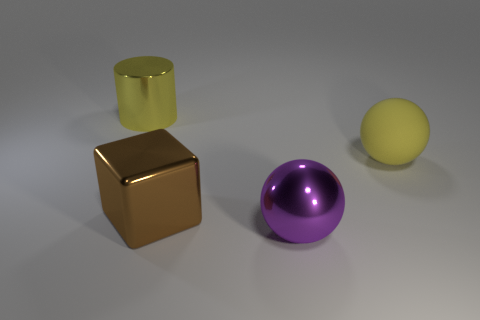Which objects in the image are reflective? The bronze cube and the purple ball appear to have reflective surfaces, showing some light specular highlights that suggest a glossy finish. 